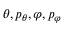Convert formula to latex. <formula><loc_0><loc_0><loc_500><loc_500>\theta , p _ { \theta } , \varphi , p _ { \varphi }</formula> 